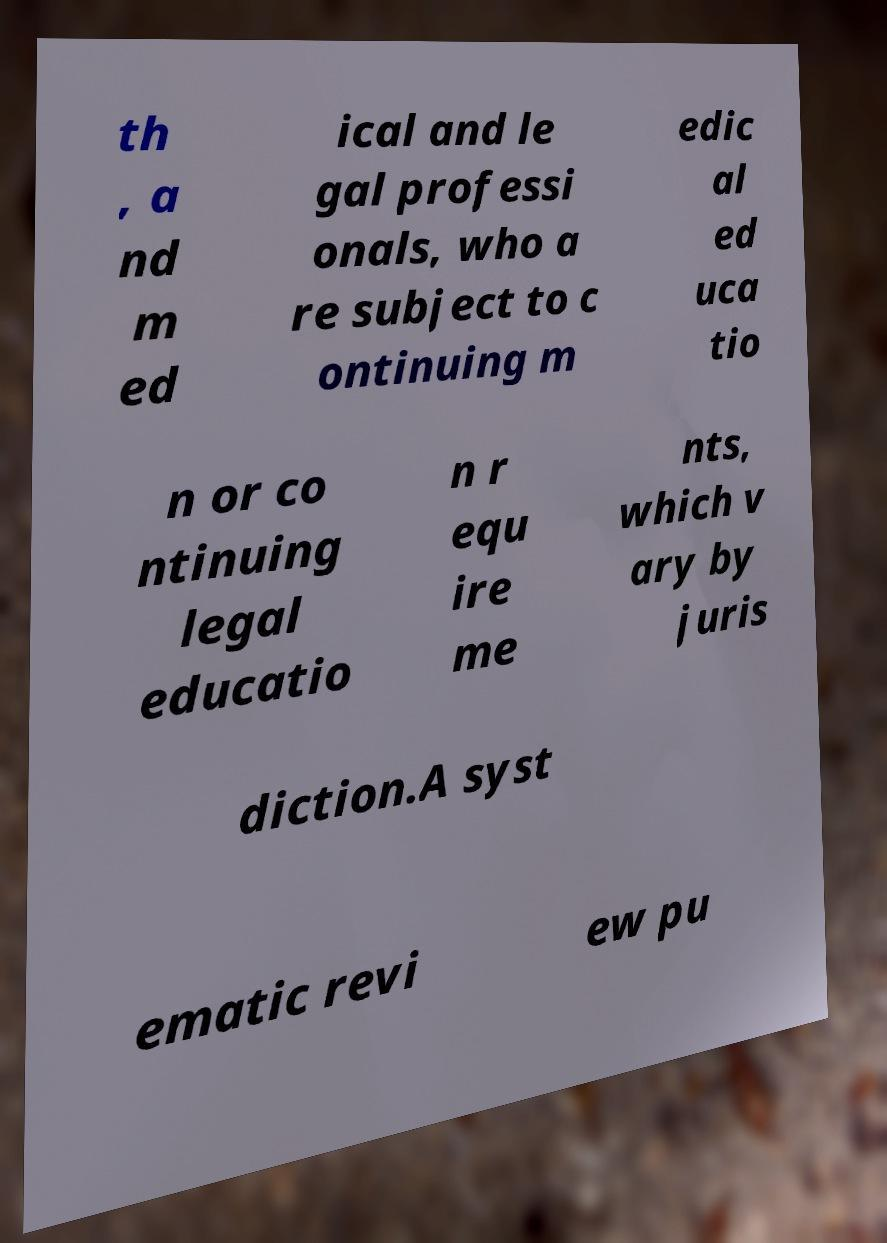There's text embedded in this image that I need extracted. Can you transcribe it verbatim? th , a nd m ed ical and le gal professi onals, who a re subject to c ontinuing m edic al ed uca tio n or co ntinuing legal educatio n r equ ire me nts, which v ary by juris diction.A syst ematic revi ew pu 